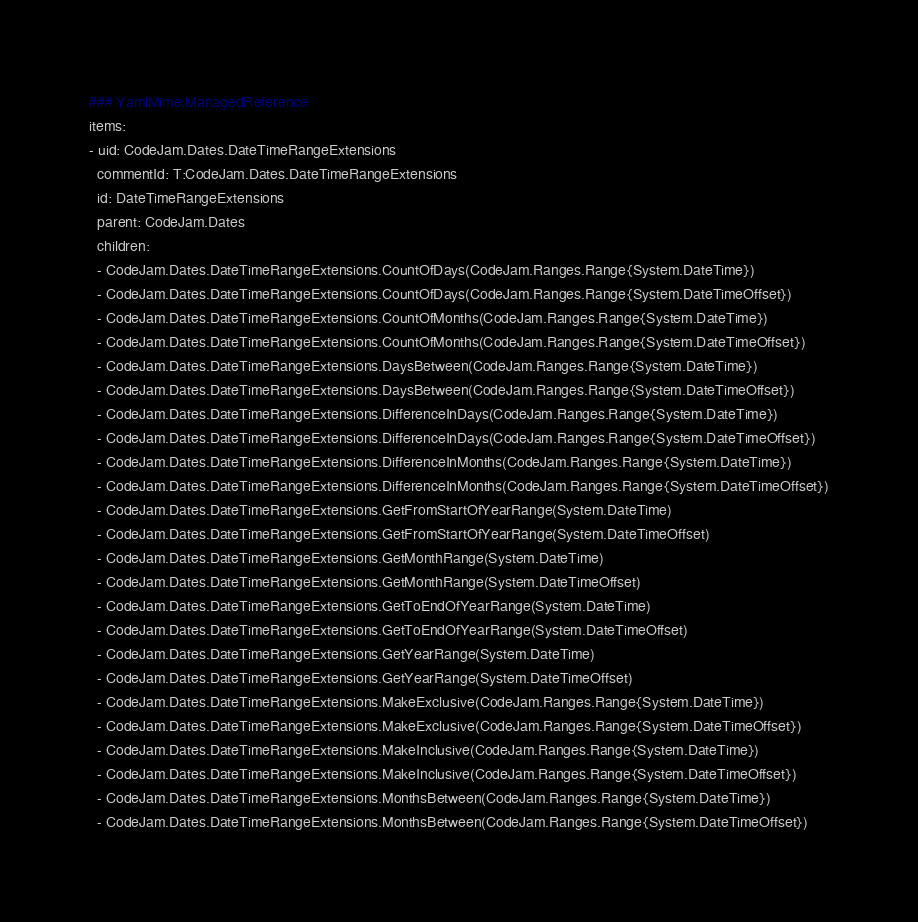Convert code to text. <code><loc_0><loc_0><loc_500><loc_500><_YAML_>### YamlMime:ManagedReference
items:
- uid: CodeJam.Dates.DateTimeRangeExtensions
  commentId: T:CodeJam.Dates.DateTimeRangeExtensions
  id: DateTimeRangeExtensions
  parent: CodeJam.Dates
  children:
  - CodeJam.Dates.DateTimeRangeExtensions.CountOfDays(CodeJam.Ranges.Range{System.DateTime})
  - CodeJam.Dates.DateTimeRangeExtensions.CountOfDays(CodeJam.Ranges.Range{System.DateTimeOffset})
  - CodeJam.Dates.DateTimeRangeExtensions.CountOfMonths(CodeJam.Ranges.Range{System.DateTime})
  - CodeJam.Dates.DateTimeRangeExtensions.CountOfMonths(CodeJam.Ranges.Range{System.DateTimeOffset})
  - CodeJam.Dates.DateTimeRangeExtensions.DaysBetween(CodeJam.Ranges.Range{System.DateTime})
  - CodeJam.Dates.DateTimeRangeExtensions.DaysBetween(CodeJam.Ranges.Range{System.DateTimeOffset})
  - CodeJam.Dates.DateTimeRangeExtensions.DifferenceInDays(CodeJam.Ranges.Range{System.DateTime})
  - CodeJam.Dates.DateTimeRangeExtensions.DifferenceInDays(CodeJam.Ranges.Range{System.DateTimeOffset})
  - CodeJam.Dates.DateTimeRangeExtensions.DifferenceInMonths(CodeJam.Ranges.Range{System.DateTime})
  - CodeJam.Dates.DateTimeRangeExtensions.DifferenceInMonths(CodeJam.Ranges.Range{System.DateTimeOffset})
  - CodeJam.Dates.DateTimeRangeExtensions.GetFromStartOfYearRange(System.DateTime)
  - CodeJam.Dates.DateTimeRangeExtensions.GetFromStartOfYearRange(System.DateTimeOffset)
  - CodeJam.Dates.DateTimeRangeExtensions.GetMonthRange(System.DateTime)
  - CodeJam.Dates.DateTimeRangeExtensions.GetMonthRange(System.DateTimeOffset)
  - CodeJam.Dates.DateTimeRangeExtensions.GetToEndOfYearRange(System.DateTime)
  - CodeJam.Dates.DateTimeRangeExtensions.GetToEndOfYearRange(System.DateTimeOffset)
  - CodeJam.Dates.DateTimeRangeExtensions.GetYearRange(System.DateTime)
  - CodeJam.Dates.DateTimeRangeExtensions.GetYearRange(System.DateTimeOffset)
  - CodeJam.Dates.DateTimeRangeExtensions.MakeExclusive(CodeJam.Ranges.Range{System.DateTime})
  - CodeJam.Dates.DateTimeRangeExtensions.MakeExclusive(CodeJam.Ranges.Range{System.DateTimeOffset})
  - CodeJam.Dates.DateTimeRangeExtensions.MakeInclusive(CodeJam.Ranges.Range{System.DateTime})
  - CodeJam.Dates.DateTimeRangeExtensions.MakeInclusive(CodeJam.Ranges.Range{System.DateTimeOffset})
  - CodeJam.Dates.DateTimeRangeExtensions.MonthsBetween(CodeJam.Ranges.Range{System.DateTime})
  - CodeJam.Dates.DateTimeRangeExtensions.MonthsBetween(CodeJam.Ranges.Range{System.DateTimeOffset})</code> 